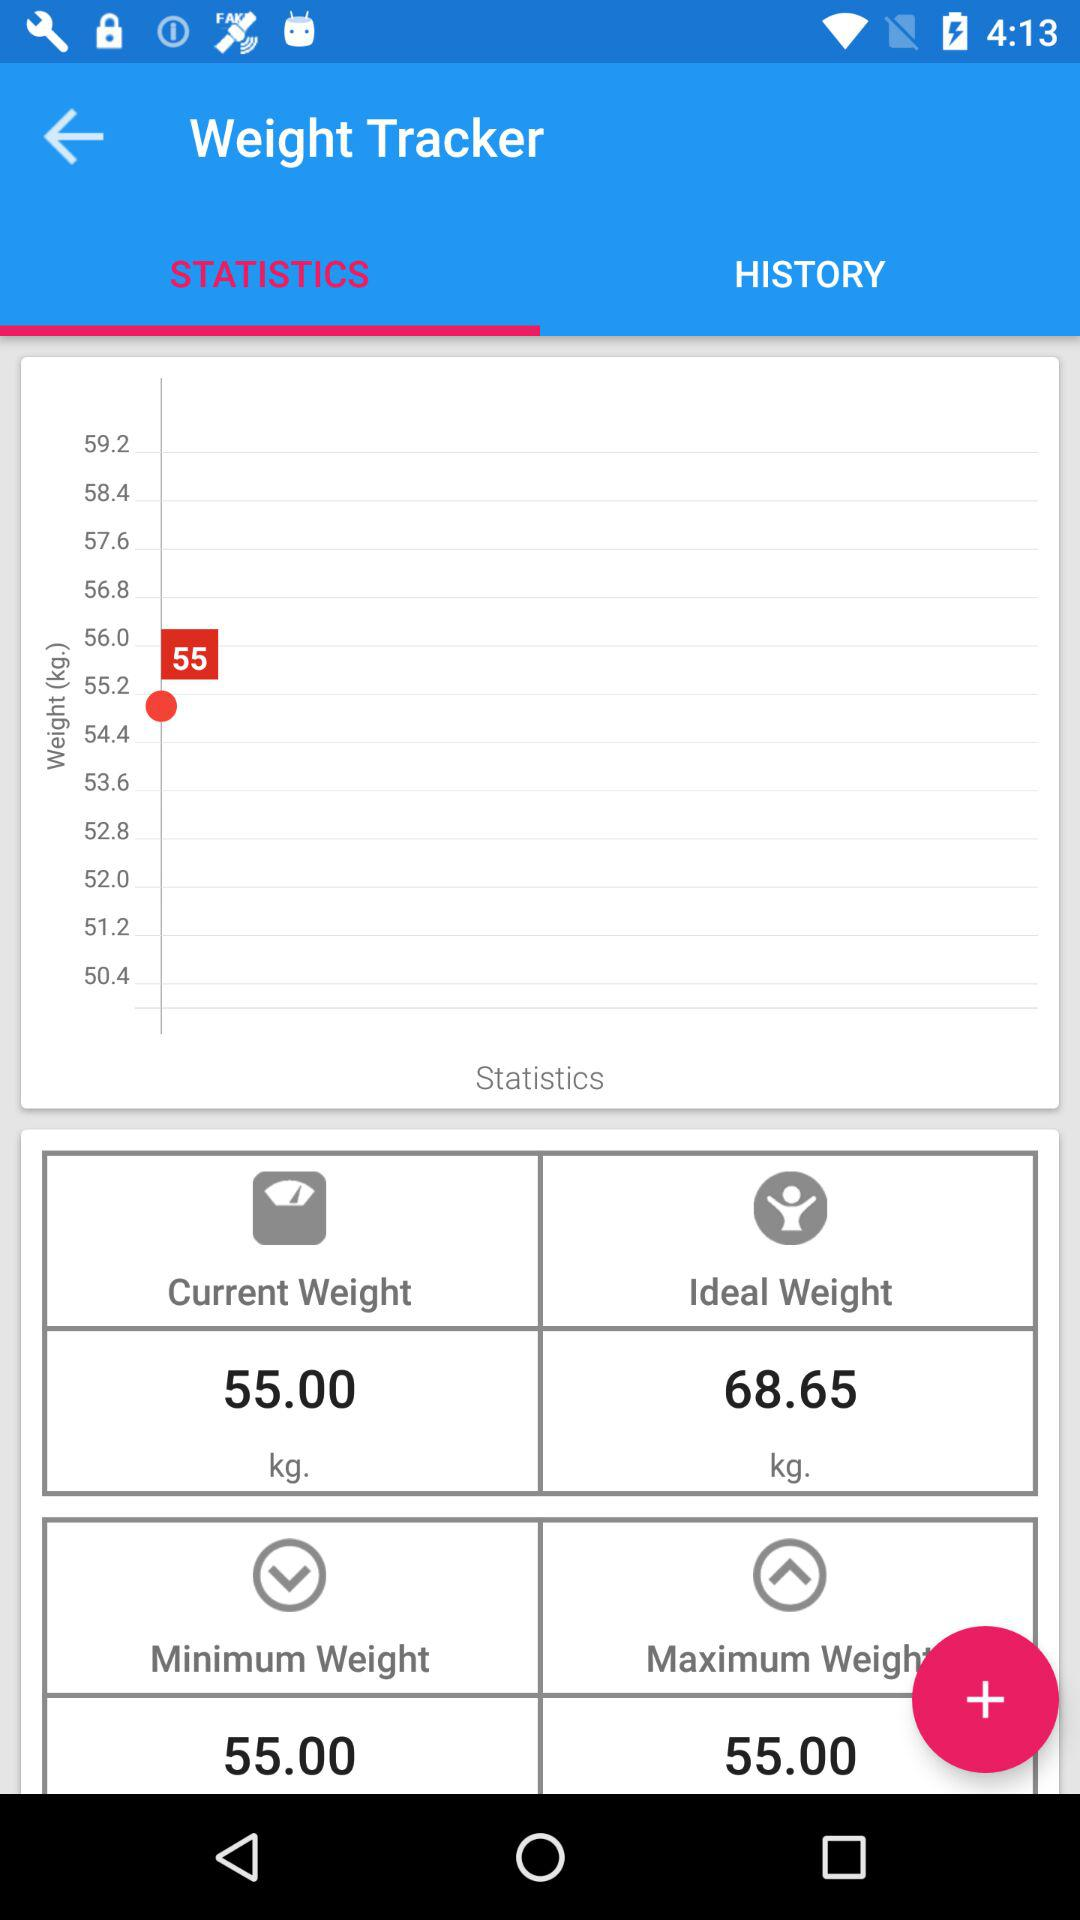Which tab is selected? The selected tab is "STATISTICS". 